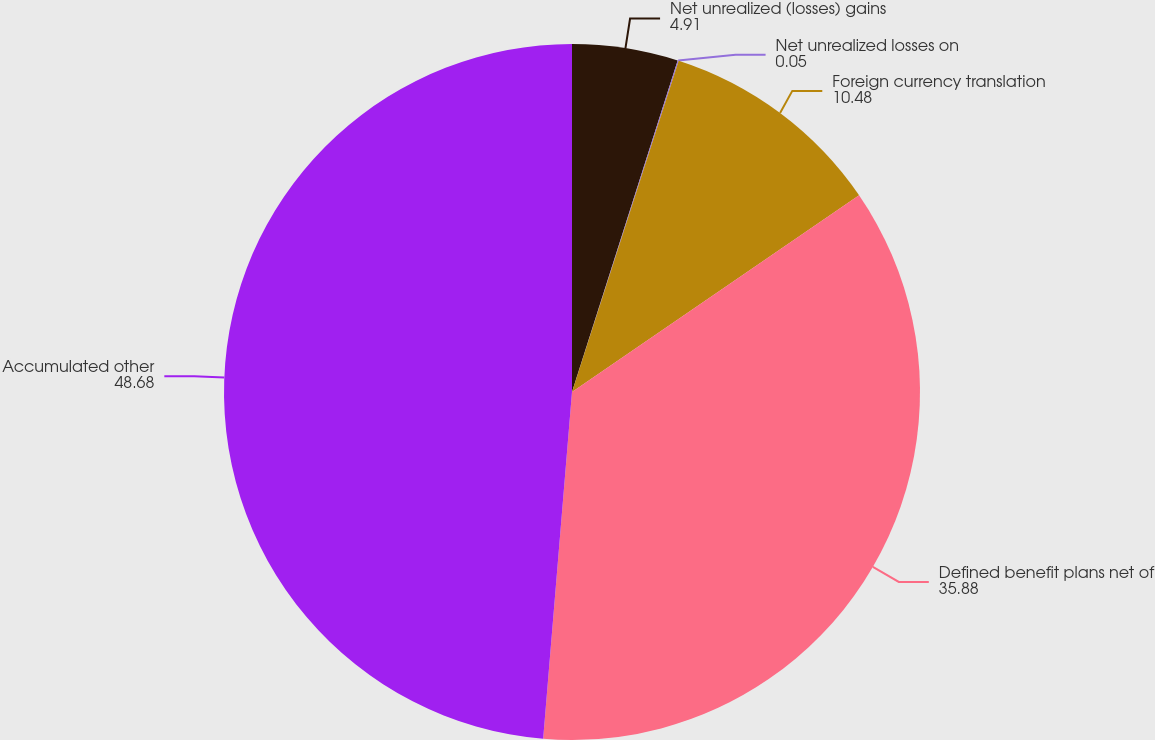Convert chart to OTSL. <chart><loc_0><loc_0><loc_500><loc_500><pie_chart><fcel>Net unrealized (losses) gains<fcel>Net unrealized losses on<fcel>Foreign currency translation<fcel>Defined benefit plans net of<fcel>Accumulated other<nl><fcel>4.91%<fcel>0.05%<fcel>10.48%<fcel>35.88%<fcel>48.68%<nl></chart> 